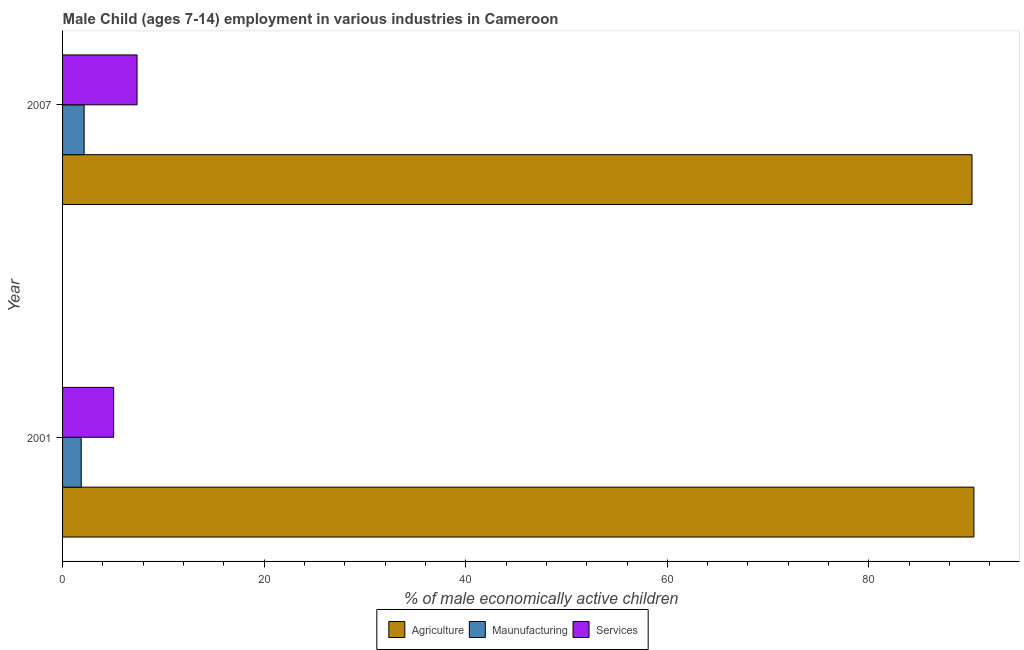How many different coloured bars are there?
Your answer should be very brief. 3. Are the number of bars per tick equal to the number of legend labels?
Your response must be concise. Yes. How many bars are there on the 1st tick from the top?
Offer a very short reply. 3. What is the percentage of economically active children in manufacturing in 2007?
Your answer should be very brief. 2.14. Across all years, what is the maximum percentage of economically active children in agriculture?
Offer a very short reply. 90.42. Across all years, what is the minimum percentage of economically active children in manufacturing?
Make the answer very short. 1.85. In which year was the percentage of economically active children in services minimum?
Provide a succinct answer. 2001. What is the total percentage of economically active children in manufacturing in the graph?
Provide a succinct answer. 3.99. What is the difference between the percentage of economically active children in agriculture in 2001 and that in 2007?
Offer a very short reply. 0.19. What is the difference between the percentage of economically active children in manufacturing in 2007 and the percentage of economically active children in services in 2001?
Ensure brevity in your answer.  -2.93. What is the average percentage of economically active children in manufacturing per year?
Your response must be concise. 2. In the year 2001, what is the difference between the percentage of economically active children in services and percentage of economically active children in agriculture?
Your answer should be compact. -85.35. In how many years, is the percentage of economically active children in agriculture greater than 72 %?
Your response must be concise. 2. What is the ratio of the percentage of economically active children in manufacturing in 2001 to that in 2007?
Offer a terse response. 0.86. Is the percentage of economically active children in manufacturing in 2001 less than that in 2007?
Offer a terse response. Yes. In how many years, is the percentage of economically active children in manufacturing greater than the average percentage of economically active children in manufacturing taken over all years?
Give a very brief answer. 1. What does the 2nd bar from the top in 2007 represents?
Your response must be concise. Maunufacturing. What does the 3rd bar from the bottom in 2001 represents?
Provide a succinct answer. Services. How many bars are there?
Provide a short and direct response. 6. How many legend labels are there?
Provide a succinct answer. 3. What is the title of the graph?
Ensure brevity in your answer.  Male Child (ages 7-14) employment in various industries in Cameroon. Does "Agriculture" appear as one of the legend labels in the graph?
Give a very brief answer. Yes. What is the label or title of the X-axis?
Give a very brief answer. % of male economically active children. What is the label or title of the Y-axis?
Your answer should be compact. Year. What is the % of male economically active children in Agriculture in 2001?
Your answer should be compact. 90.42. What is the % of male economically active children of Maunufacturing in 2001?
Keep it short and to the point. 1.85. What is the % of male economically active children in Services in 2001?
Ensure brevity in your answer.  5.07. What is the % of male economically active children of Agriculture in 2007?
Give a very brief answer. 90.23. What is the % of male economically active children of Maunufacturing in 2007?
Give a very brief answer. 2.14. What is the % of male economically active children of Services in 2007?
Give a very brief answer. 7.39. Across all years, what is the maximum % of male economically active children of Agriculture?
Provide a short and direct response. 90.42. Across all years, what is the maximum % of male economically active children of Maunufacturing?
Ensure brevity in your answer.  2.14. Across all years, what is the maximum % of male economically active children of Services?
Make the answer very short. 7.39. Across all years, what is the minimum % of male economically active children of Agriculture?
Ensure brevity in your answer.  90.23. Across all years, what is the minimum % of male economically active children in Maunufacturing?
Provide a short and direct response. 1.85. Across all years, what is the minimum % of male economically active children of Services?
Your answer should be very brief. 5.07. What is the total % of male economically active children of Agriculture in the graph?
Offer a very short reply. 180.65. What is the total % of male economically active children of Maunufacturing in the graph?
Your answer should be compact. 3.99. What is the total % of male economically active children in Services in the graph?
Your answer should be compact. 12.46. What is the difference between the % of male economically active children in Agriculture in 2001 and that in 2007?
Offer a terse response. 0.19. What is the difference between the % of male economically active children of Maunufacturing in 2001 and that in 2007?
Make the answer very short. -0.29. What is the difference between the % of male economically active children in Services in 2001 and that in 2007?
Give a very brief answer. -2.32. What is the difference between the % of male economically active children of Agriculture in 2001 and the % of male economically active children of Maunufacturing in 2007?
Give a very brief answer. 88.28. What is the difference between the % of male economically active children of Agriculture in 2001 and the % of male economically active children of Services in 2007?
Your answer should be very brief. 83.03. What is the difference between the % of male economically active children of Maunufacturing in 2001 and the % of male economically active children of Services in 2007?
Offer a very short reply. -5.54. What is the average % of male economically active children of Agriculture per year?
Your response must be concise. 90.33. What is the average % of male economically active children of Maunufacturing per year?
Give a very brief answer. 2. What is the average % of male economically active children of Services per year?
Your answer should be very brief. 6.23. In the year 2001, what is the difference between the % of male economically active children in Agriculture and % of male economically active children in Maunufacturing?
Your answer should be compact. 88.57. In the year 2001, what is the difference between the % of male economically active children of Agriculture and % of male economically active children of Services?
Offer a very short reply. 85.35. In the year 2001, what is the difference between the % of male economically active children in Maunufacturing and % of male economically active children in Services?
Your response must be concise. -3.22. In the year 2007, what is the difference between the % of male economically active children in Agriculture and % of male economically active children in Maunufacturing?
Make the answer very short. 88.09. In the year 2007, what is the difference between the % of male economically active children in Agriculture and % of male economically active children in Services?
Make the answer very short. 82.84. In the year 2007, what is the difference between the % of male economically active children of Maunufacturing and % of male economically active children of Services?
Make the answer very short. -5.25. What is the ratio of the % of male economically active children in Maunufacturing in 2001 to that in 2007?
Ensure brevity in your answer.  0.86. What is the ratio of the % of male economically active children in Services in 2001 to that in 2007?
Ensure brevity in your answer.  0.69. What is the difference between the highest and the second highest % of male economically active children in Agriculture?
Offer a terse response. 0.19. What is the difference between the highest and the second highest % of male economically active children in Maunufacturing?
Your answer should be compact. 0.29. What is the difference between the highest and the second highest % of male economically active children of Services?
Your answer should be compact. 2.32. What is the difference between the highest and the lowest % of male economically active children of Agriculture?
Your answer should be compact. 0.19. What is the difference between the highest and the lowest % of male economically active children of Maunufacturing?
Provide a succinct answer. 0.29. What is the difference between the highest and the lowest % of male economically active children in Services?
Provide a succinct answer. 2.32. 